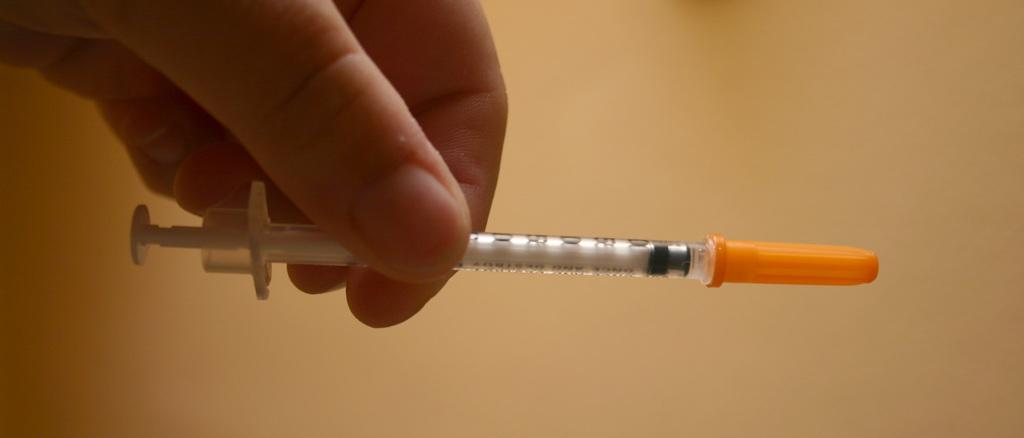What is the main object in the image? There is an unopened injection in the image. Who is holding the injection? The injection is being held by someone. What color is the cap of the injection? The cap of the injection is orange. How many crates are stacked next to the person holding the injection? There are no crates present in the image. What type of necklace is the person wearing in the image? There is no necklace visible in the image. 